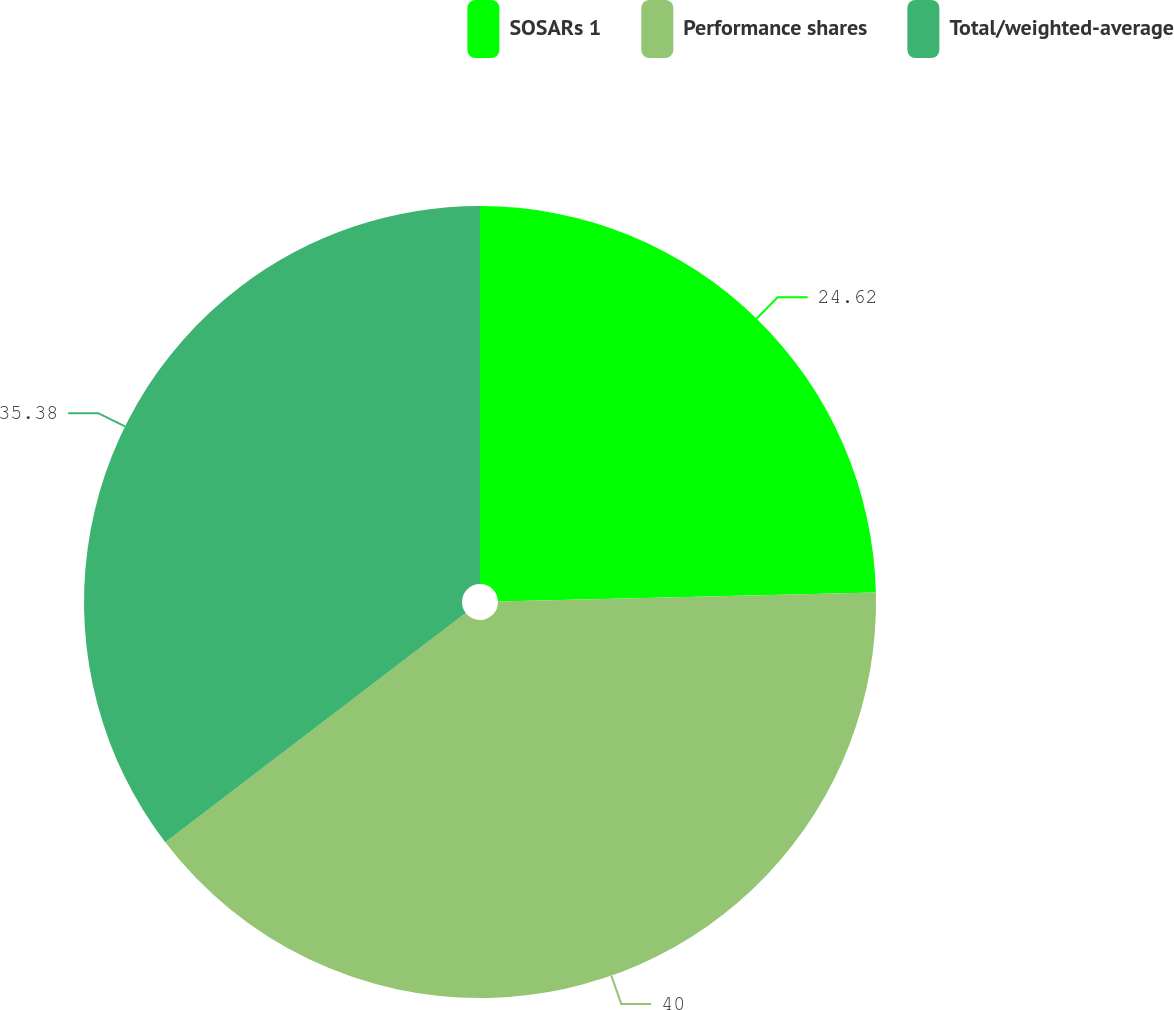<chart> <loc_0><loc_0><loc_500><loc_500><pie_chart><fcel>SOSARs 1<fcel>Performance shares<fcel>Total/weighted-average<nl><fcel>24.62%<fcel>40.0%<fcel>35.38%<nl></chart> 